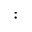<formula> <loc_0><loc_0><loc_500><loc_500>\colon</formula> 